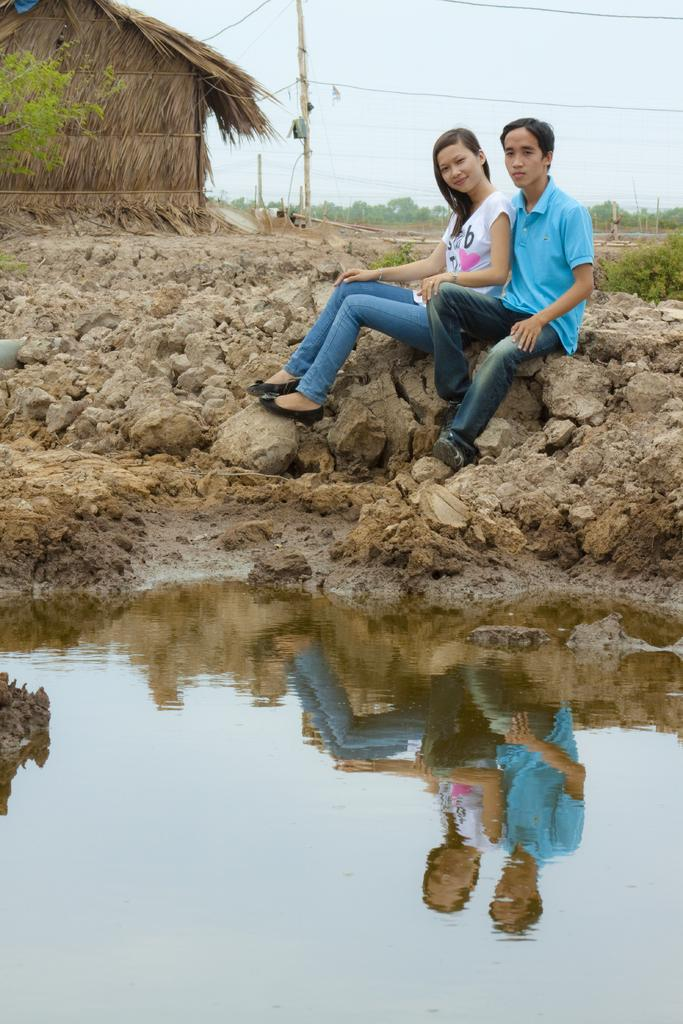How many people are present in the image? There is a man and a woman present in the image. What are the man and woman doing in the image? The man and woman are seated on rocks in the image. What can be seen in front of the man and woman? There is water visible in front of them. What type of vegetation is visible in the background of the image? There are trees in the background of the image. What structures can be seen in the background of the image? There is a pole and a hut visible in the background of the image. What type of notebook is the man using to write in the image? There is no notebook present in the image. 